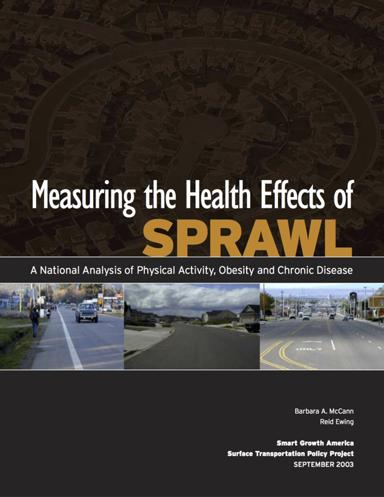What is the main topic of the brochure? The brochure is focused on "Measuring the Health Effects of Sprawl: A National Analysis of Physical Activity, Obesity, and Chronic Disease." It delves into how urban sprawl impacts public health, specifically looking into its relationships with physical activity levels, obesity rates, and chronic health conditions. 